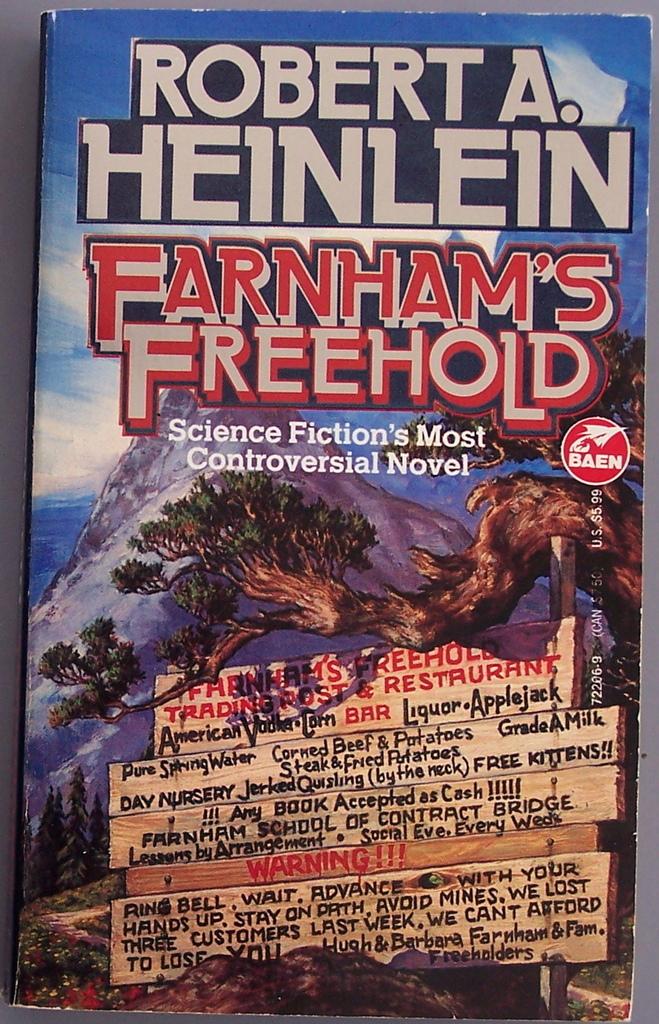Who made this?
Make the answer very short. Robert a. heinlein. What is the title of the book?
Ensure brevity in your answer.  Farnham's freehold. 